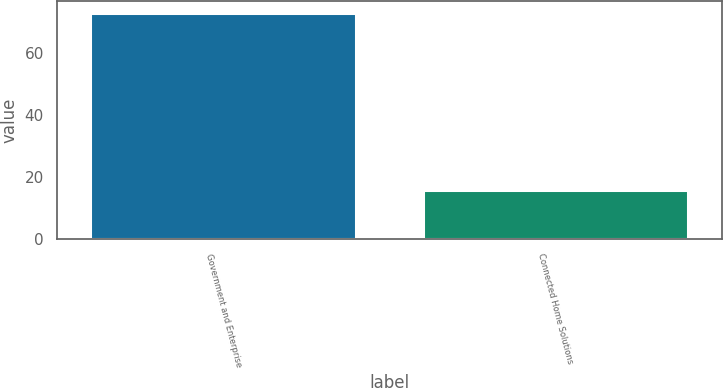<chart> <loc_0><loc_0><loc_500><loc_500><bar_chart><fcel>Government and Enterprise<fcel>Connected Home Solutions<nl><fcel>73<fcel>16<nl></chart> 